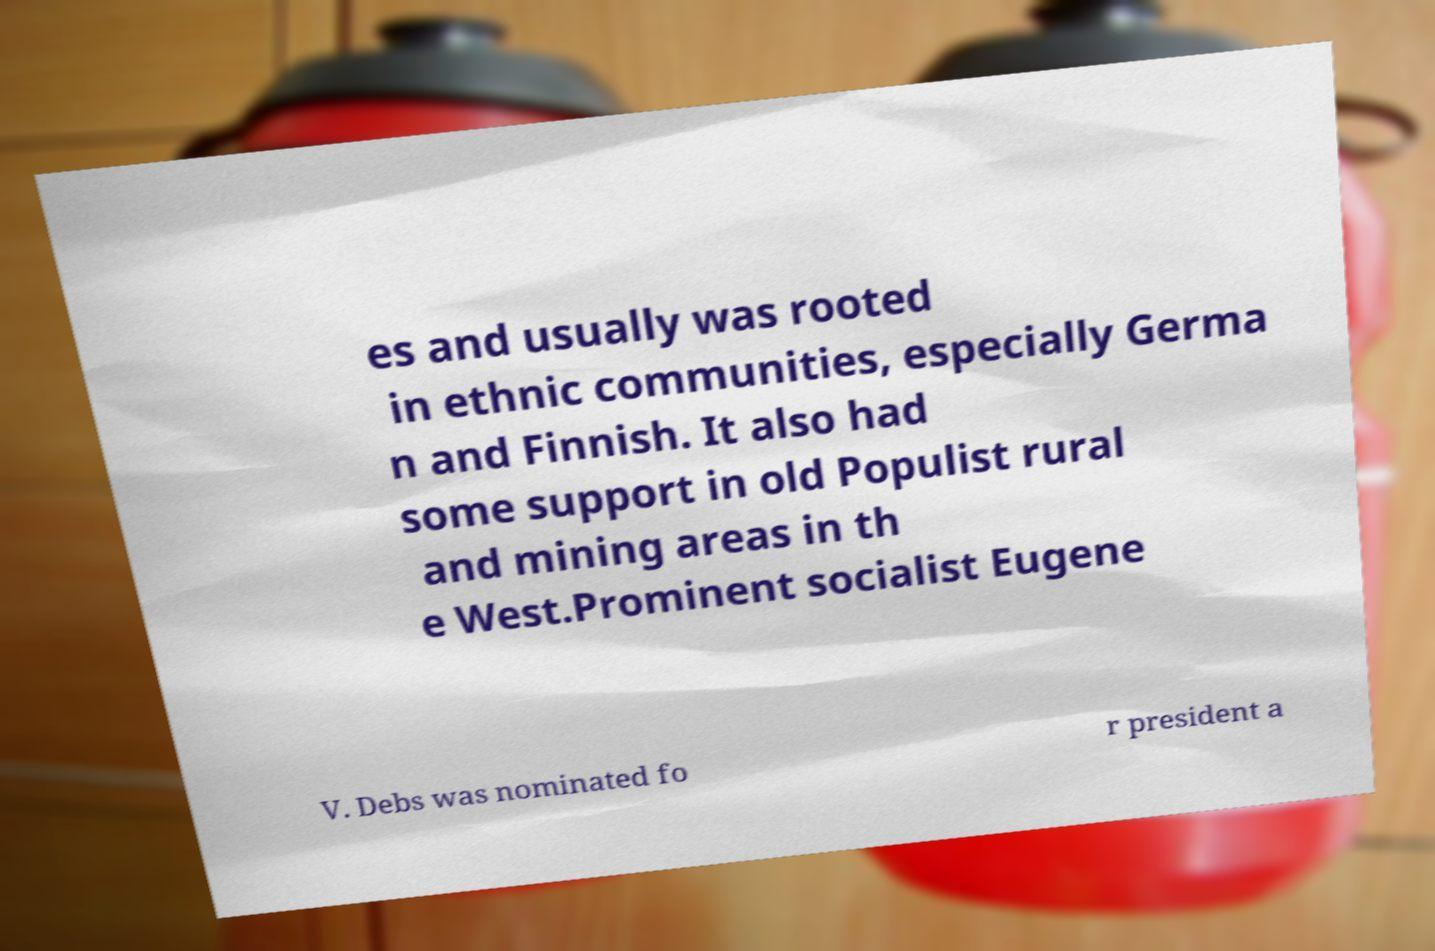Can you read and provide the text displayed in the image?This photo seems to have some interesting text. Can you extract and type it out for me? es and usually was rooted in ethnic communities, especially Germa n and Finnish. It also had some support in old Populist rural and mining areas in th e West.Prominent socialist Eugene V. Debs was nominated fo r president a 